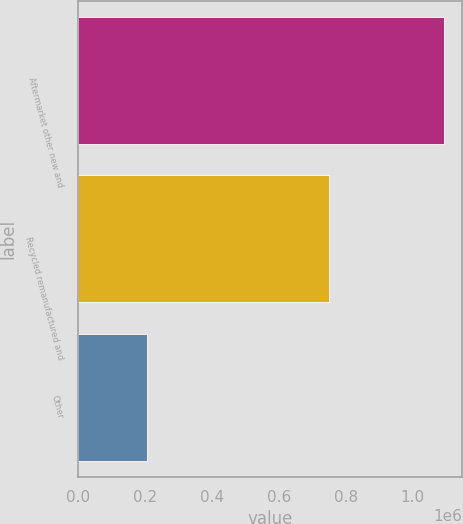Convert chart to OTSL. <chart><loc_0><loc_0><loc_500><loc_500><bar_chart><fcel>Aftermarket other new and<fcel>Recycled remanufactured and<fcel>Other<nl><fcel>1.09316e+06<fcel>749012<fcel>205773<nl></chart> 